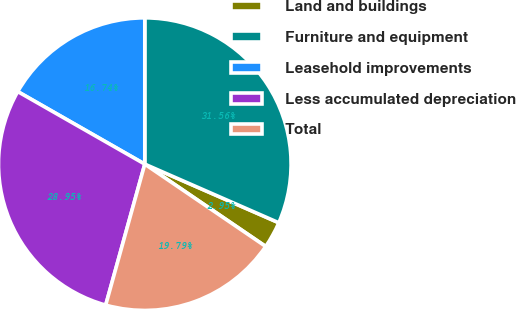<chart> <loc_0><loc_0><loc_500><loc_500><pie_chart><fcel>Land and buildings<fcel>Furniture and equipment<fcel>Leasehold improvements<fcel>Less accumulated depreciation<fcel>Total<nl><fcel>2.95%<fcel>31.56%<fcel>16.74%<fcel>28.95%<fcel>19.79%<nl></chart> 